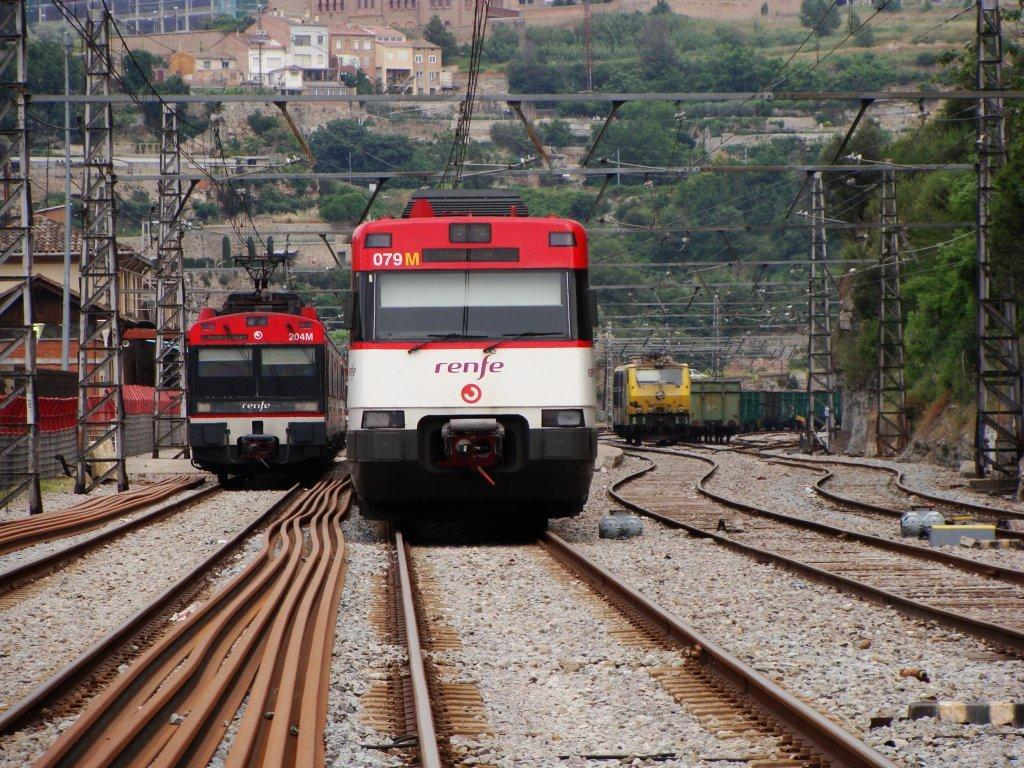What is located at the bottom of the image? There are train tracks with trains at the bottom of the image. What can be seen running alongside the train tracks? There are many poles with electrical wires in the image. What type of natural scenery is visible in the background of the image? There are trees in the background of the image. What type of man-made structures can be seen in the background of the image? There are buildings in the background of the image. What is the reason for the distribution of earth in the image? There is no mention of earth or its distribution in the image. The image primarily features train tracks, electrical wires, trees, and buildings. 